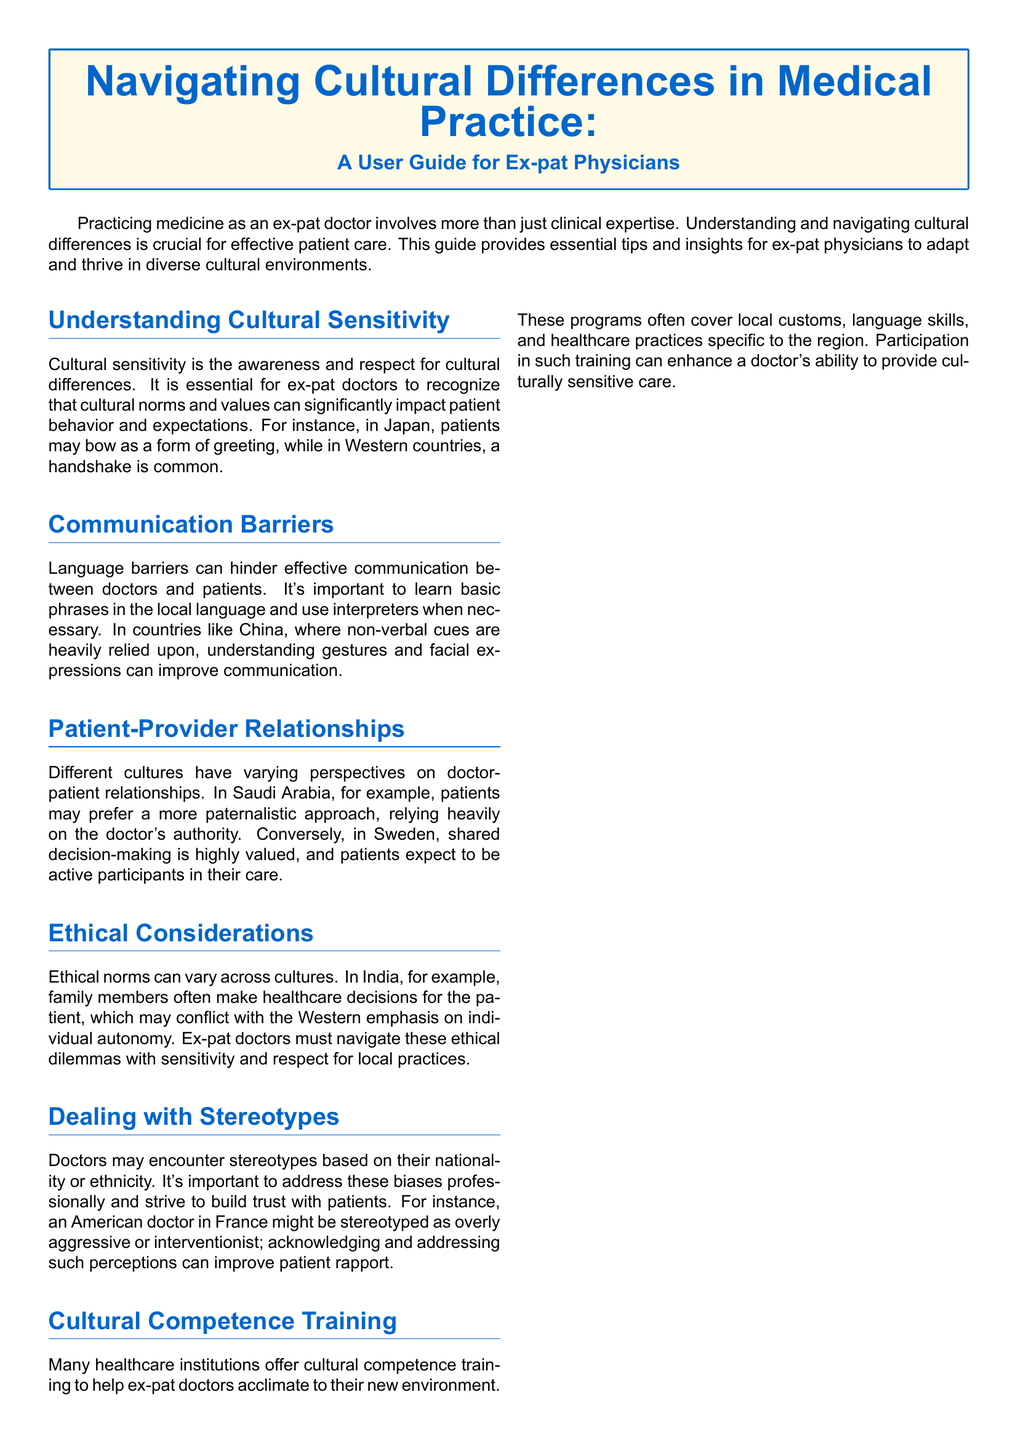What is the main topic of the user guide? The main topic of the user guide is navigating cultural differences in medical practice for ex-pat physicians.
Answer: Navigating cultural differences in medical practice What is one aspect of cultural sensitivity mentioned? One aspect mentioned is recognizing that cultural norms can impact patient behavior.
Answer: Impact on patient behavior What type of communication barriers are highlighted? Language barriers are highlighted as a significant communication challenge.
Answer: Language barriers In which country might patients prefer a paternalistic approach? Patients in Saudi Arabia may prefer a paternalistic approach.
Answer: Saudi Arabia What is a common stereotype American doctors may face in France? An American doctor in France might be stereotyped as overly aggressive.
Answer: Overly aggressive What type of training can help ex-pat doctors? Cultural competence training can help ex-pat doctors adjust.
Answer: Cultural competence training What is a key ethical consideration for ex-pat doctors in India? Family members often make healthcare decisions for the patient in India.
Answer: Family decision-making How does the user guide describe the process of navigating cultural differences? It describes it as a continual learning process.
Answer: Continual learning process What local practice should ex-pat doctors respect in different cultures? Ex-pat doctors need to respect local ethical norms and practices.
Answer: Local ethical norms 